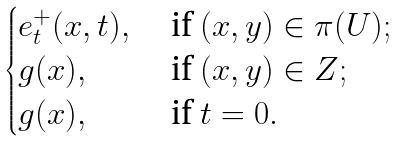<formula> <loc_0><loc_0><loc_500><loc_500>\begin{cases} e _ { t } ^ { + } ( x , t ) , & \text { if } ( x , y ) \in \pi ( U ) ; \\ g ( x ) , & \text { if } ( x , y ) \in Z ; \\ g ( x ) , & \text { if } t = 0 . \end{cases}</formula> 